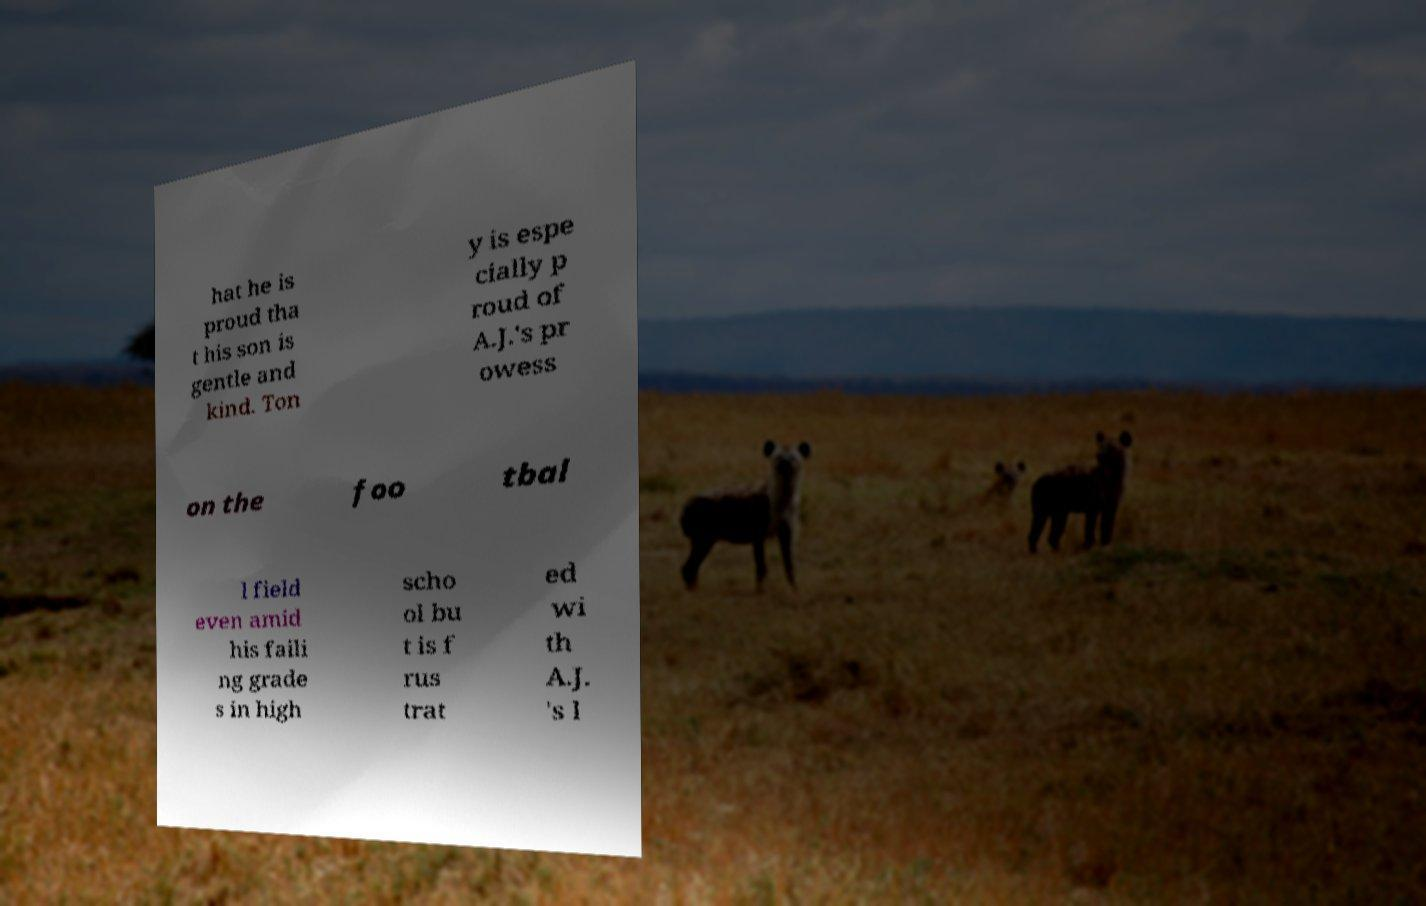Could you assist in decoding the text presented in this image and type it out clearly? hat he is proud tha t his son is gentle and kind. Ton y is espe cially p roud of A.J.'s pr owess on the foo tbal l field even amid his faili ng grade s in high scho ol bu t is f rus trat ed wi th A.J. 's l 